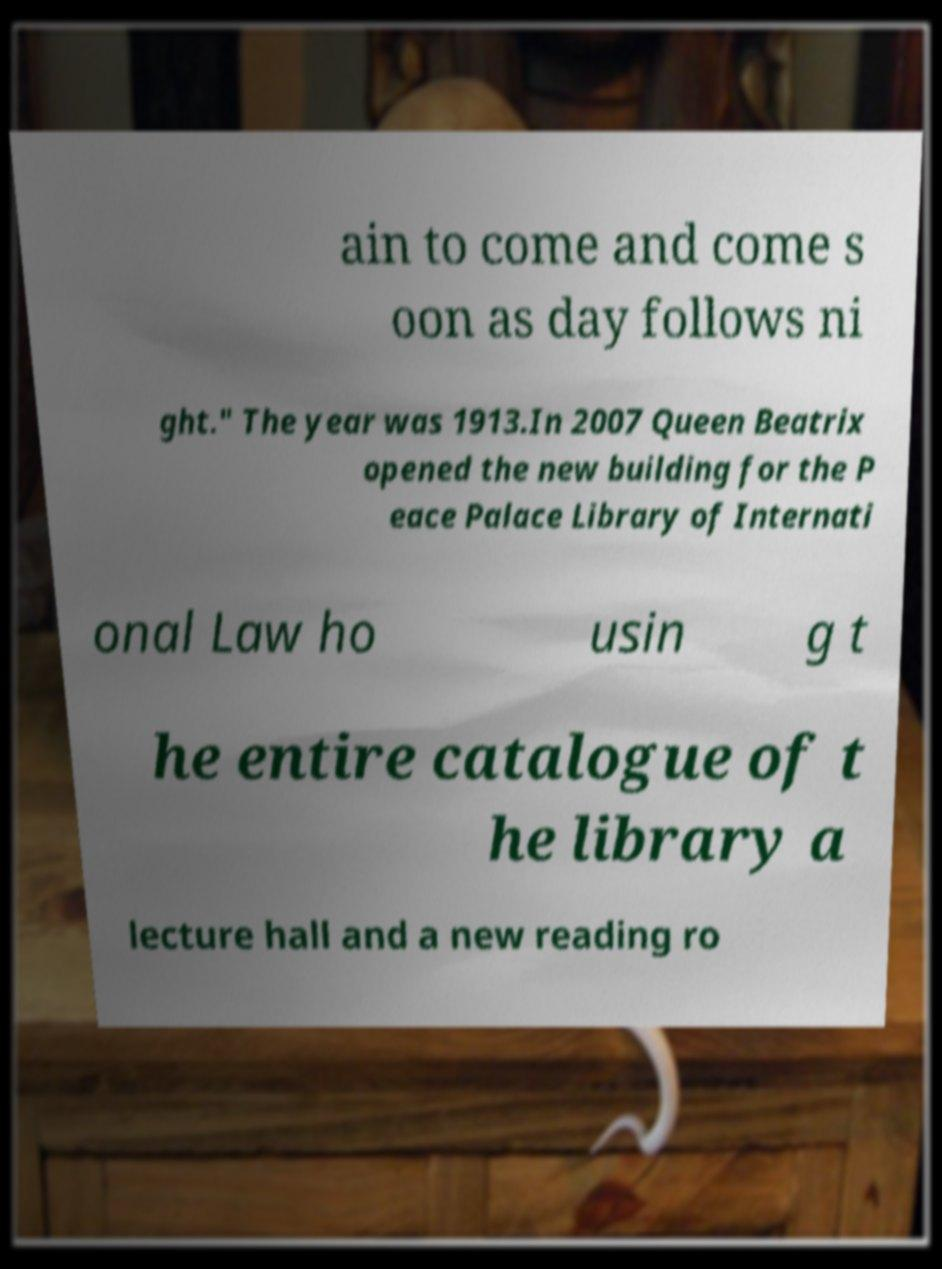Please read and relay the text visible in this image. What does it say? ain to come and come s oon as day follows ni ght." The year was 1913.In 2007 Queen Beatrix opened the new building for the P eace Palace Library of Internati onal Law ho usin g t he entire catalogue of t he library a lecture hall and a new reading ro 